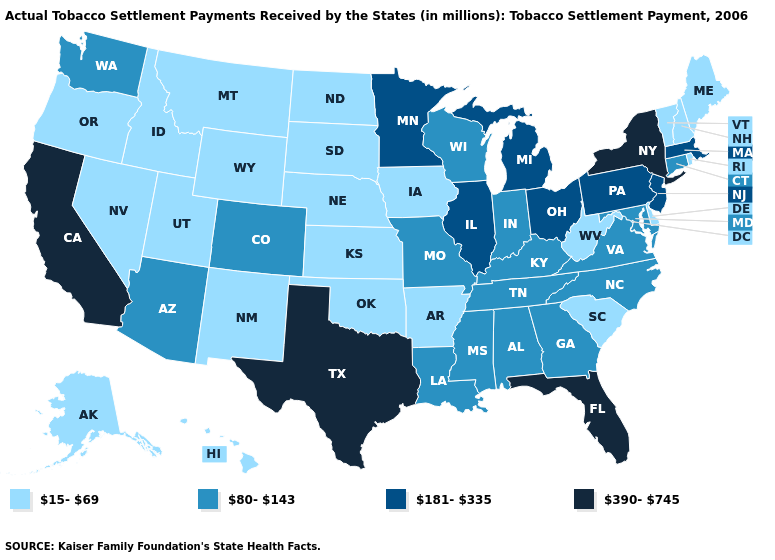Which states have the lowest value in the USA?
Write a very short answer. Alaska, Arkansas, Delaware, Hawaii, Idaho, Iowa, Kansas, Maine, Montana, Nebraska, Nevada, New Hampshire, New Mexico, North Dakota, Oklahoma, Oregon, Rhode Island, South Carolina, South Dakota, Utah, Vermont, West Virginia, Wyoming. Does Indiana have the lowest value in the USA?
Short answer required. No. Among the states that border North Carolina , does Virginia have the lowest value?
Quick response, please. No. Name the states that have a value in the range 390-745?
Answer briefly. California, Florida, New York, Texas. Does Alaska have a lower value than Michigan?
Answer briefly. Yes. Is the legend a continuous bar?
Short answer required. No. Does New Mexico have a higher value than Washington?
Quick response, please. No. What is the value of Florida?
Write a very short answer. 390-745. What is the value of Alaska?
Give a very brief answer. 15-69. What is the lowest value in states that border Virginia?
Quick response, please. 15-69. Which states have the lowest value in the West?
Short answer required. Alaska, Hawaii, Idaho, Montana, Nevada, New Mexico, Oregon, Utah, Wyoming. What is the value of Michigan?
Short answer required. 181-335. What is the value of Kentucky?
Keep it brief. 80-143. Does Utah have a lower value than North Dakota?
Short answer required. No. Does the map have missing data?
Short answer required. No. 